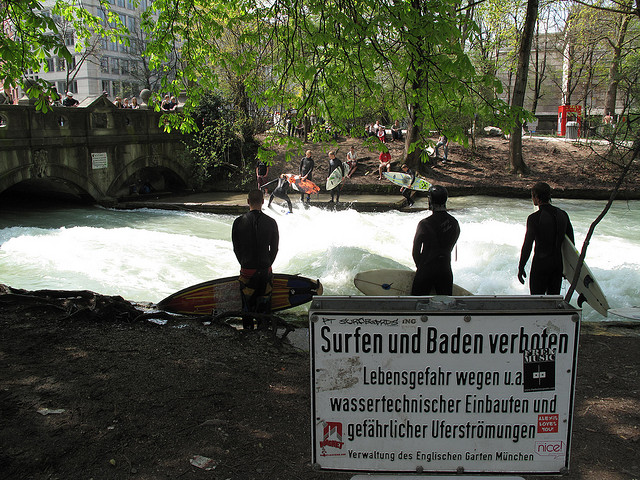Please identify all text content in this image. Surfen und Baden wegen wassertechnischer Verwaltung des englischen Garten Munchen nicel uferstromungen gefahrlicher und Einbauten Lebensgefahr u.a. MUSIC verboten 